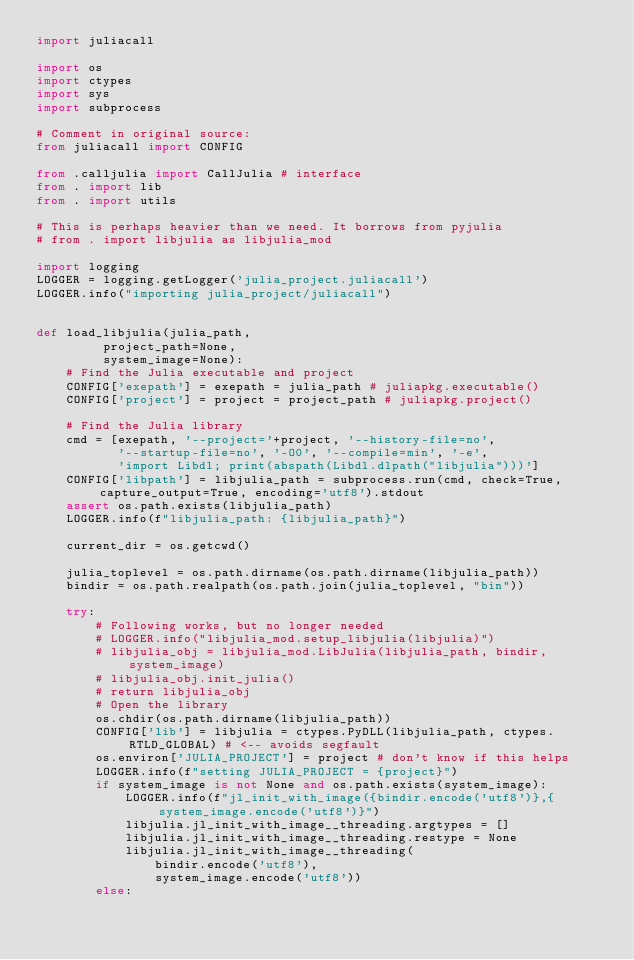<code> <loc_0><loc_0><loc_500><loc_500><_Python_>import juliacall

import os
import ctypes
import sys
import subprocess

# Comment in original source:
from juliacall import CONFIG

from .calljulia import CallJulia # interface
from . import lib
from . import utils

# This is perhaps heavier than we need. It borrows from pyjulia
# from . import libjulia as libjulia_mod

import logging
LOGGER = logging.getLogger('julia_project.juliacall')
LOGGER.info("importing julia_project/juliacall")


def load_libjulia(julia_path,
         project_path=None,
         system_image=None):
    # Find the Julia executable and project
    CONFIG['exepath'] = exepath = julia_path # juliapkg.executable()
    CONFIG['project'] = project = project_path # juliapkg.project()

    # Find the Julia library
    cmd = [exepath, '--project='+project, '--history-file=no',
           '--startup-file=no', '-O0', '--compile=min', '-e',
           'import Libdl; print(abspath(Libdl.dlpath("libjulia")))']
    CONFIG['libpath'] = libjulia_path = subprocess.run(cmd, check=True, capture_output=True, encoding='utf8').stdout
    assert os.path.exists(libjulia_path)
    LOGGER.info(f"libjulia_path: {libjulia_path}")

    current_dir = os.getcwd()

    julia_toplevel = os.path.dirname(os.path.dirname(libjulia_path))
    bindir = os.path.realpath(os.path.join(julia_toplevel, "bin"))

    try:
        # Following works, but no longer needed
        # LOGGER.info("libjulia_mod.setup_libjulia(libjulia)")
        # libjulia_obj = libjulia_mod.LibJulia(libjulia_path, bindir, system_image)
        # libjulia_obj.init_julia()
        # return libjulia_obj
        # Open the library
        os.chdir(os.path.dirname(libjulia_path))
        CONFIG['lib'] = libjulia = ctypes.PyDLL(libjulia_path, ctypes.RTLD_GLOBAL) # <-- avoids segfault
        os.environ['JULIA_PROJECT'] = project # don't know if this helps
        LOGGER.info(f"setting JULIA_PROJECT = {project}")
        if system_image is not None and os.path.exists(system_image):
            LOGGER.info(f"jl_init_with_image({bindir.encode('utf8')},{system_image.encode('utf8')}")
            libjulia.jl_init_with_image__threading.argtypes = []
            libjulia.jl_init_with_image__threading.restype = None
            libjulia.jl_init_with_image__threading(
                bindir.encode('utf8'),
                system_image.encode('utf8'))
        else:</code> 